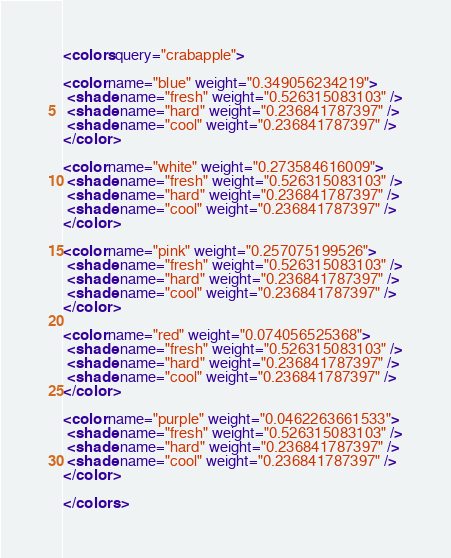<code> <loc_0><loc_0><loc_500><loc_500><_XML_><colors query="crabapple">

<color name="blue" weight="0.349056234219">
 <shade name="fresh" weight="0.526315083103" />
 <shade name="hard" weight="0.236841787397" />
 <shade name="cool" weight="0.236841787397" />
</color>

<color name="white" weight="0.273584616009">
 <shade name="fresh" weight="0.526315083103" />
 <shade name="hard" weight="0.236841787397" />
 <shade name="cool" weight="0.236841787397" />
</color>

<color name="pink" weight="0.257075199526">
 <shade name="fresh" weight="0.526315083103" />
 <shade name="hard" weight="0.236841787397" />
 <shade name="cool" weight="0.236841787397" />
</color>

<color name="red" weight="0.074056525368">
 <shade name="fresh" weight="0.526315083103" />
 <shade name="hard" weight="0.236841787397" />
 <shade name="cool" weight="0.236841787397" />
</color>

<color name="purple" weight="0.0462263661533">
 <shade name="fresh" weight="0.526315083103" />
 <shade name="hard" weight="0.236841787397" />
 <shade name="cool" weight="0.236841787397" />
</color>

</colors></code> 